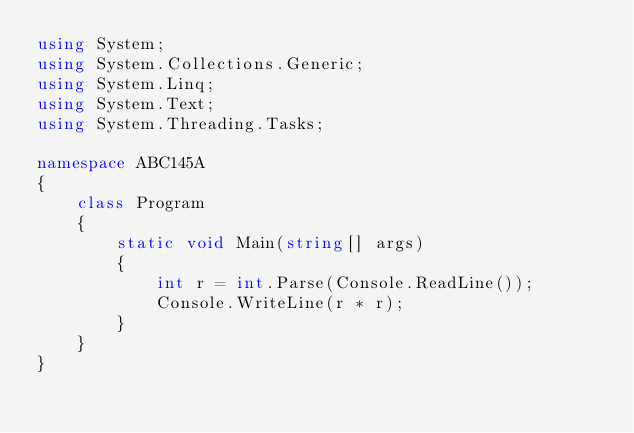Convert code to text. <code><loc_0><loc_0><loc_500><loc_500><_C#_>using System;
using System.Collections.Generic;
using System.Linq;
using System.Text;
using System.Threading.Tasks;

namespace ABC145A
{
    class Program
    {
        static void Main(string[] args)
        {
            int r = int.Parse(Console.ReadLine());
            Console.WriteLine(r * r);
        }
    }
}
</code> 